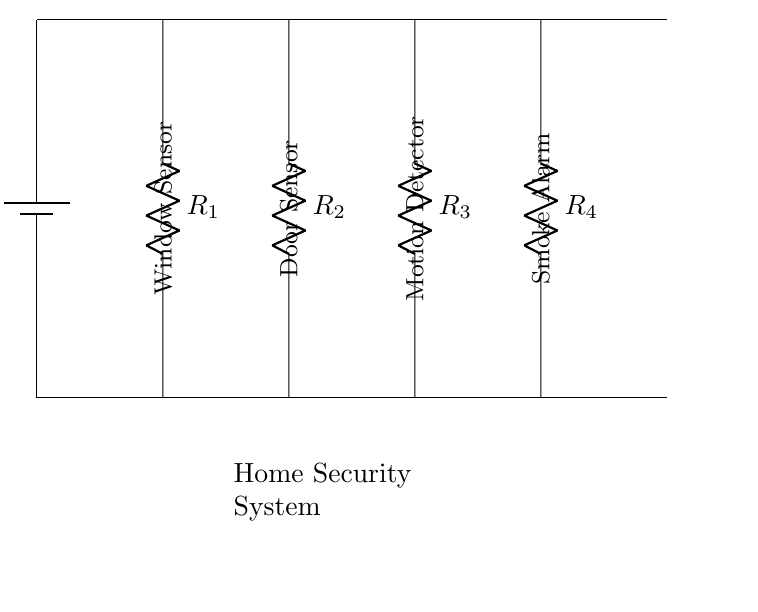What type of circuit is this? The circuit is a parallel circuit, which can be identified by the components being connected across common voltage points rather than in a single path.
Answer: Parallel circuit How many sensors are included in this security system? There are four sensors connected in parallel, as shown by the four resistors labeled in the diagram.
Answer: Four What is the purpose of the battery in this circuit? The battery provides the necessary voltage to power all the sensors in the parallel circuit, allowing them to operate simultaneously.
Answer: Power supply What do the resistors represent in this circuit? The resistors represent the various sensors in the home security system, each with its own resistance, which is typical for such components.
Answer: Sensors What is the total current supplying the sensors? In a parallel circuit, the total current is the sum of the individual currents through each sensor, allowing each to operate independently without affecting the others.
Answer: Sum of individual currents Why is the circuit designed in parallel for a security system? A parallel design ensures that if one sensor fails, the others will continue to function, providing continuous protection for the home security system.
Answer: Continuity of operation 